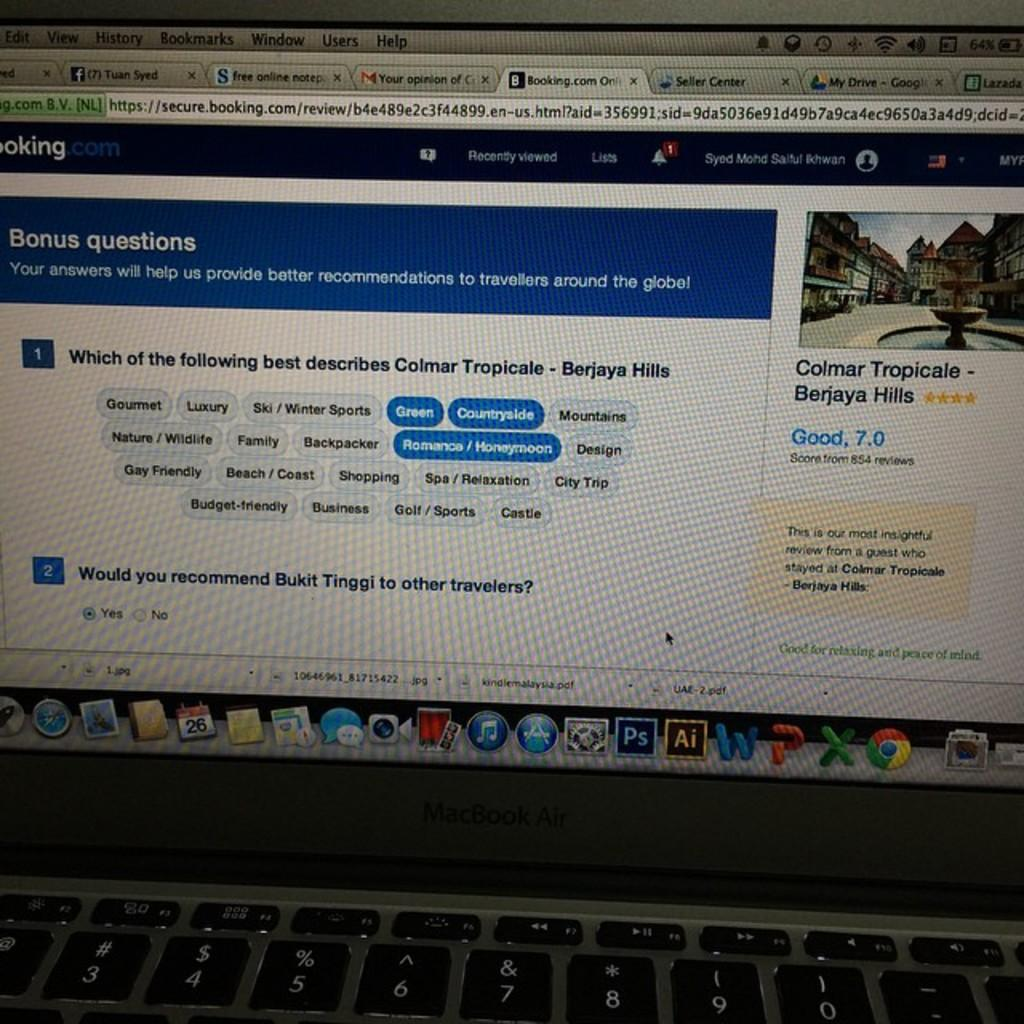<image>
Summarize the visual content of the image. A laptop with facebook pulled up to a page titled "Bonus questions" 